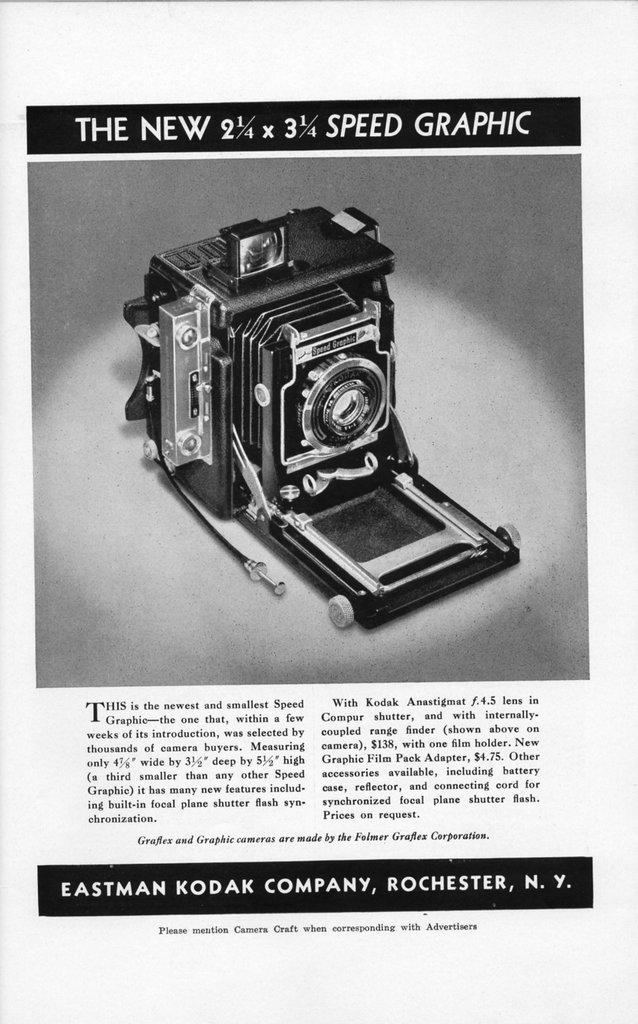What is present on the paper in the image? The paper contains a camera picture and text. Can you describe the content of the camera picture on the paper? Unfortunately, the specific content of the camera picture cannot be determined from the image. What type of information is written on the paper? The text on the paper is not legible in the image, so the content cannot be determined. What type of pencil is being used by the laborer on the floor in the image? There is no laborer or pencil present on the floor in the image. 